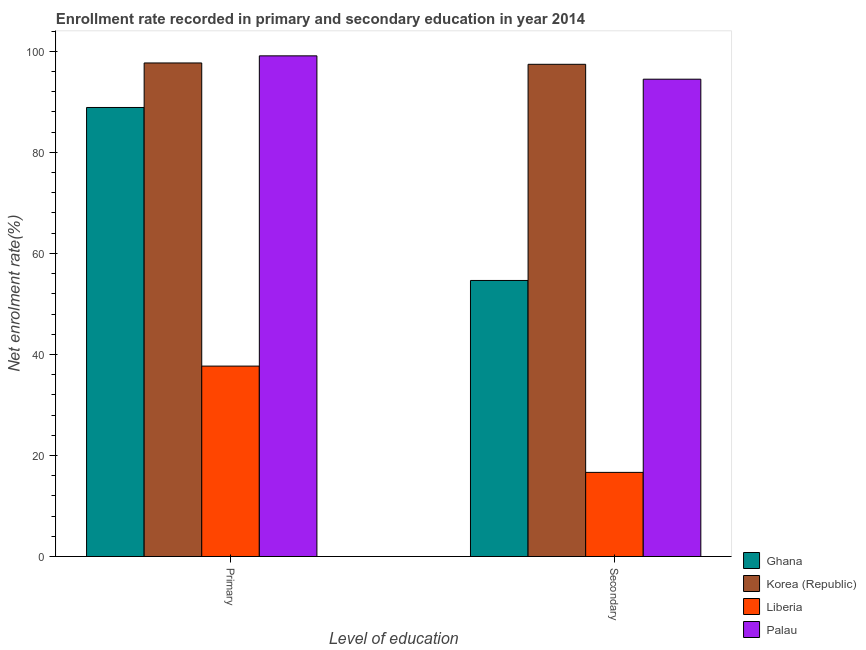How many different coloured bars are there?
Give a very brief answer. 4. How many groups of bars are there?
Provide a succinct answer. 2. Are the number of bars per tick equal to the number of legend labels?
Provide a short and direct response. Yes. How many bars are there on the 1st tick from the right?
Make the answer very short. 4. What is the label of the 2nd group of bars from the left?
Your answer should be compact. Secondary. What is the enrollment rate in secondary education in Liberia?
Your answer should be very brief. 16.65. Across all countries, what is the maximum enrollment rate in primary education?
Make the answer very short. 99.09. Across all countries, what is the minimum enrollment rate in secondary education?
Offer a terse response. 16.65. In which country was the enrollment rate in secondary education minimum?
Offer a terse response. Liberia. What is the total enrollment rate in secondary education in the graph?
Your response must be concise. 263.19. What is the difference between the enrollment rate in primary education in Liberia and that in Korea (Republic)?
Make the answer very short. -60. What is the difference between the enrollment rate in primary education in Liberia and the enrollment rate in secondary education in Ghana?
Your answer should be very brief. -16.95. What is the average enrollment rate in secondary education per country?
Give a very brief answer. 65.8. What is the difference between the enrollment rate in primary education and enrollment rate in secondary education in Palau?
Provide a short and direct response. 4.62. In how many countries, is the enrollment rate in secondary education greater than 52 %?
Make the answer very short. 3. What is the ratio of the enrollment rate in primary education in Liberia to that in Ghana?
Offer a terse response. 0.42. Is the enrollment rate in secondary education in Palau less than that in Liberia?
Offer a very short reply. No. In how many countries, is the enrollment rate in primary education greater than the average enrollment rate in primary education taken over all countries?
Make the answer very short. 3. What does the 4th bar from the left in Secondary represents?
Provide a short and direct response. Palau. Are all the bars in the graph horizontal?
Provide a short and direct response. No. What is the difference between two consecutive major ticks on the Y-axis?
Your response must be concise. 20. Where does the legend appear in the graph?
Your response must be concise. Bottom right. How many legend labels are there?
Keep it short and to the point. 4. How are the legend labels stacked?
Your answer should be compact. Vertical. What is the title of the graph?
Provide a short and direct response. Enrollment rate recorded in primary and secondary education in year 2014. Does "Northern Mariana Islands" appear as one of the legend labels in the graph?
Give a very brief answer. No. What is the label or title of the X-axis?
Keep it short and to the point. Level of education. What is the label or title of the Y-axis?
Keep it short and to the point. Net enrolment rate(%). What is the Net enrolment rate(%) in Ghana in Primary?
Keep it short and to the point. 88.88. What is the Net enrolment rate(%) of Korea (Republic) in Primary?
Your answer should be compact. 97.69. What is the Net enrolment rate(%) of Liberia in Primary?
Provide a short and direct response. 37.69. What is the Net enrolment rate(%) in Palau in Primary?
Give a very brief answer. 99.09. What is the Net enrolment rate(%) of Ghana in Secondary?
Provide a succinct answer. 54.64. What is the Net enrolment rate(%) in Korea (Republic) in Secondary?
Your answer should be very brief. 97.42. What is the Net enrolment rate(%) in Liberia in Secondary?
Your answer should be compact. 16.65. What is the Net enrolment rate(%) in Palau in Secondary?
Your answer should be very brief. 94.48. Across all Level of education, what is the maximum Net enrolment rate(%) of Ghana?
Provide a succinct answer. 88.88. Across all Level of education, what is the maximum Net enrolment rate(%) in Korea (Republic)?
Keep it short and to the point. 97.69. Across all Level of education, what is the maximum Net enrolment rate(%) of Liberia?
Offer a very short reply. 37.69. Across all Level of education, what is the maximum Net enrolment rate(%) of Palau?
Your response must be concise. 99.09. Across all Level of education, what is the minimum Net enrolment rate(%) of Ghana?
Offer a very short reply. 54.64. Across all Level of education, what is the minimum Net enrolment rate(%) in Korea (Republic)?
Your answer should be very brief. 97.42. Across all Level of education, what is the minimum Net enrolment rate(%) of Liberia?
Give a very brief answer. 16.65. Across all Level of education, what is the minimum Net enrolment rate(%) in Palau?
Make the answer very short. 94.48. What is the total Net enrolment rate(%) in Ghana in the graph?
Keep it short and to the point. 143.51. What is the total Net enrolment rate(%) of Korea (Republic) in the graph?
Provide a short and direct response. 195.11. What is the total Net enrolment rate(%) in Liberia in the graph?
Make the answer very short. 54.34. What is the total Net enrolment rate(%) of Palau in the graph?
Provide a short and direct response. 193.57. What is the difference between the Net enrolment rate(%) in Ghana in Primary and that in Secondary?
Give a very brief answer. 34.24. What is the difference between the Net enrolment rate(%) of Korea (Republic) in Primary and that in Secondary?
Give a very brief answer. 0.27. What is the difference between the Net enrolment rate(%) in Liberia in Primary and that in Secondary?
Keep it short and to the point. 21.04. What is the difference between the Net enrolment rate(%) of Palau in Primary and that in Secondary?
Provide a short and direct response. 4.62. What is the difference between the Net enrolment rate(%) of Ghana in Primary and the Net enrolment rate(%) of Korea (Republic) in Secondary?
Ensure brevity in your answer.  -8.54. What is the difference between the Net enrolment rate(%) in Ghana in Primary and the Net enrolment rate(%) in Liberia in Secondary?
Offer a very short reply. 72.22. What is the difference between the Net enrolment rate(%) of Ghana in Primary and the Net enrolment rate(%) of Palau in Secondary?
Ensure brevity in your answer.  -5.6. What is the difference between the Net enrolment rate(%) in Korea (Republic) in Primary and the Net enrolment rate(%) in Liberia in Secondary?
Your answer should be compact. 81.03. What is the difference between the Net enrolment rate(%) in Korea (Republic) in Primary and the Net enrolment rate(%) in Palau in Secondary?
Offer a terse response. 3.21. What is the difference between the Net enrolment rate(%) of Liberia in Primary and the Net enrolment rate(%) of Palau in Secondary?
Your answer should be very brief. -56.79. What is the average Net enrolment rate(%) in Ghana per Level of education?
Keep it short and to the point. 71.76. What is the average Net enrolment rate(%) in Korea (Republic) per Level of education?
Make the answer very short. 97.55. What is the average Net enrolment rate(%) of Liberia per Level of education?
Provide a succinct answer. 27.17. What is the average Net enrolment rate(%) in Palau per Level of education?
Ensure brevity in your answer.  96.78. What is the difference between the Net enrolment rate(%) of Ghana and Net enrolment rate(%) of Korea (Republic) in Primary?
Your answer should be compact. -8.81. What is the difference between the Net enrolment rate(%) in Ghana and Net enrolment rate(%) in Liberia in Primary?
Offer a terse response. 51.19. What is the difference between the Net enrolment rate(%) of Ghana and Net enrolment rate(%) of Palau in Primary?
Your response must be concise. -10.22. What is the difference between the Net enrolment rate(%) of Korea (Republic) and Net enrolment rate(%) of Liberia in Primary?
Your answer should be very brief. 60. What is the difference between the Net enrolment rate(%) of Korea (Republic) and Net enrolment rate(%) of Palau in Primary?
Provide a short and direct response. -1.41. What is the difference between the Net enrolment rate(%) in Liberia and Net enrolment rate(%) in Palau in Primary?
Provide a succinct answer. -61.4. What is the difference between the Net enrolment rate(%) of Ghana and Net enrolment rate(%) of Korea (Republic) in Secondary?
Ensure brevity in your answer.  -42.78. What is the difference between the Net enrolment rate(%) in Ghana and Net enrolment rate(%) in Liberia in Secondary?
Offer a terse response. 37.98. What is the difference between the Net enrolment rate(%) of Ghana and Net enrolment rate(%) of Palau in Secondary?
Offer a very short reply. -39.84. What is the difference between the Net enrolment rate(%) in Korea (Republic) and Net enrolment rate(%) in Liberia in Secondary?
Offer a very short reply. 80.77. What is the difference between the Net enrolment rate(%) of Korea (Republic) and Net enrolment rate(%) of Palau in Secondary?
Your answer should be compact. 2.95. What is the difference between the Net enrolment rate(%) of Liberia and Net enrolment rate(%) of Palau in Secondary?
Ensure brevity in your answer.  -77.82. What is the ratio of the Net enrolment rate(%) in Ghana in Primary to that in Secondary?
Offer a very short reply. 1.63. What is the ratio of the Net enrolment rate(%) of Korea (Republic) in Primary to that in Secondary?
Your answer should be compact. 1. What is the ratio of the Net enrolment rate(%) of Liberia in Primary to that in Secondary?
Your answer should be very brief. 2.26. What is the ratio of the Net enrolment rate(%) of Palau in Primary to that in Secondary?
Your response must be concise. 1.05. What is the difference between the highest and the second highest Net enrolment rate(%) of Ghana?
Your answer should be very brief. 34.24. What is the difference between the highest and the second highest Net enrolment rate(%) of Korea (Republic)?
Provide a short and direct response. 0.27. What is the difference between the highest and the second highest Net enrolment rate(%) of Liberia?
Ensure brevity in your answer.  21.04. What is the difference between the highest and the second highest Net enrolment rate(%) in Palau?
Your answer should be very brief. 4.62. What is the difference between the highest and the lowest Net enrolment rate(%) in Ghana?
Ensure brevity in your answer.  34.24. What is the difference between the highest and the lowest Net enrolment rate(%) of Korea (Republic)?
Offer a terse response. 0.27. What is the difference between the highest and the lowest Net enrolment rate(%) in Liberia?
Offer a terse response. 21.04. What is the difference between the highest and the lowest Net enrolment rate(%) in Palau?
Your answer should be compact. 4.62. 